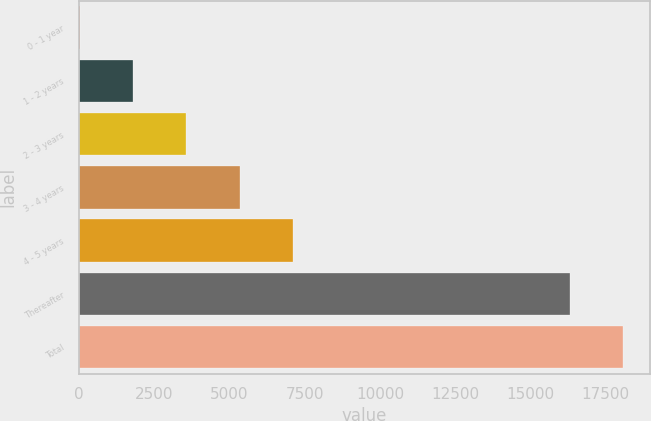Convert chart to OTSL. <chart><loc_0><loc_0><loc_500><loc_500><bar_chart><fcel>0 - 1 year<fcel>1 - 2 years<fcel>2 - 3 years<fcel>3 - 4 years<fcel>4 - 5 years<fcel>Thereafter<fcel>Total<nl><fcel>16<fcel>1789.1<fcel>3562.2<fcel>5335.3<fcel>7108.4<fcel>16309<fcel>18082.1<nl></chart> 